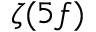<formula> <loc_0><loc_0><loc_500><loc_500>\zeta ( 5 f )</formula> 